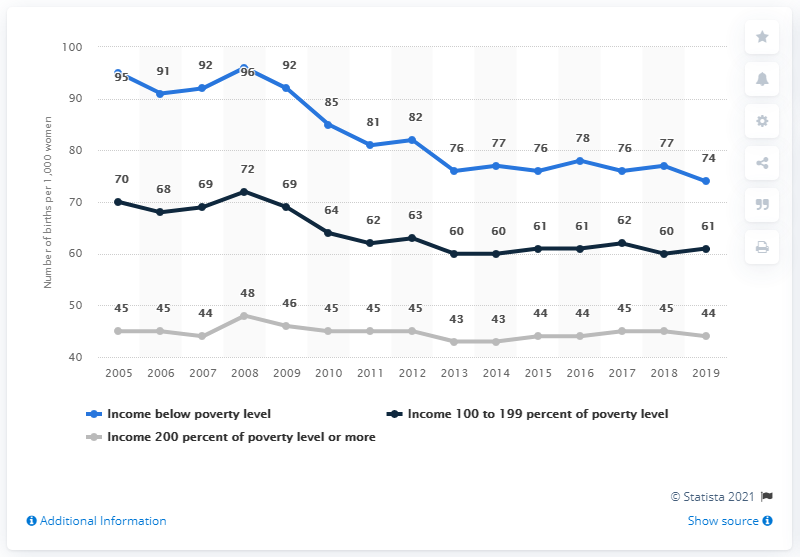Highlight a few significant elements in this photo. In 2008, income levels at 100 to 199 percent of the poverty level were considered high. The average income for individuals below the poverty level is 83.2%. The birth rate among women living in households with income below the poverty threshold was 74 per 1,000 in.. 